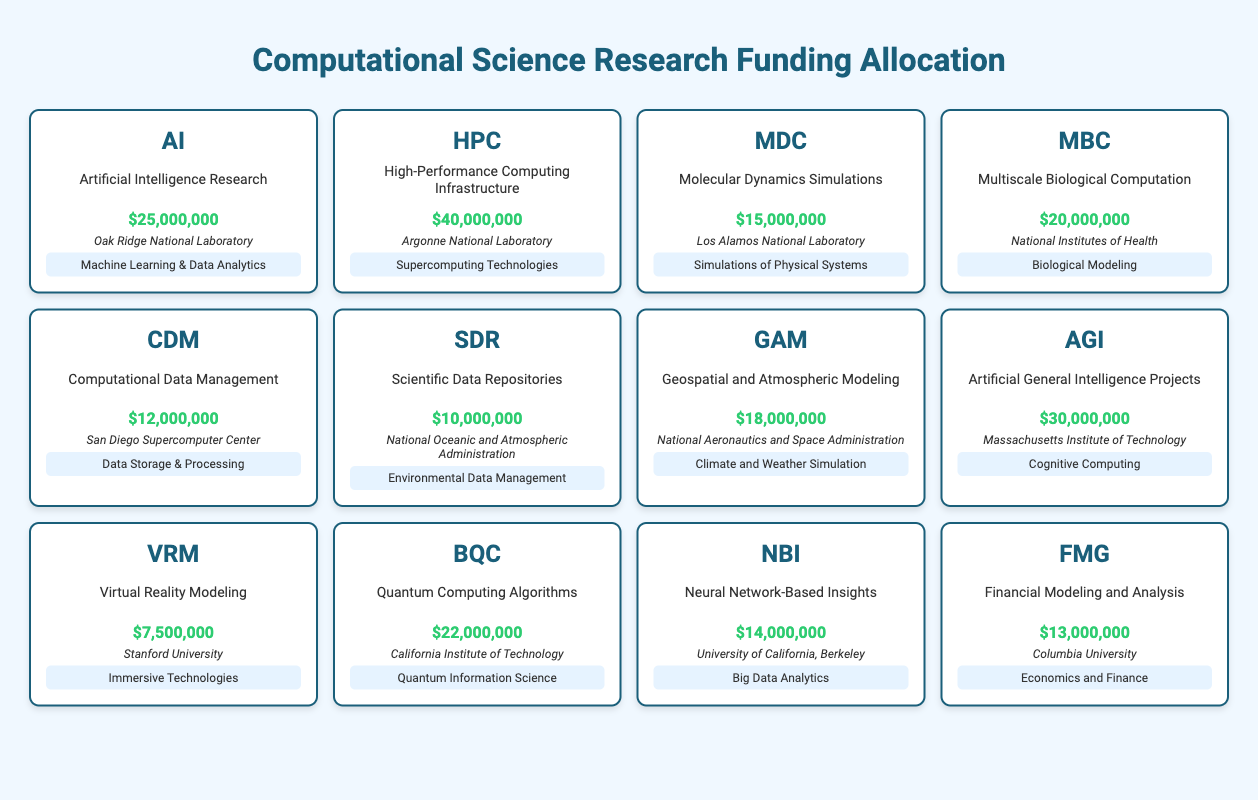What is the total funding for projects focusing on Machine Learning & Data Analytics? There is one project related to Machine Learning & Data Analytics, which is "Artificial Intelligence Research" with funding of 25,000,000. Therefore, the total funding for this focus area is 25,000,000.
Answer: 25,000,000 Which project received the highest funding and what is the amount? The project "High-Performance Computing Infrastructure" received the highest funding of 40,000,000.
Answer: High-Performance Computing Infrastructure, 40,000,000 How much more funding does the "Geospatial and Atmospheric Modeling" project have compared to the "Virtual Reality Modeling" project? "Geospatial and Atmospheric Modeling" has funding of 18,000,000 and "Virtual Reality Modeling" has funding of 7,500,000. So, the difference is 18,000,000 - 7,500,000 = 10,500,000.
Answer: 10,500,000 Is the funding for "Quantum Computing Algorithms" greater than that of "Neural Network-Based Insights"? "Quantum Computing Algorithms" has funding of 22,000,000, while "Neural Network-Based Insights" has funding of 14,000,000. Since 22,000,000 is greater than 14,000,000, the answer is yes.
Answer: Yes What is the average funding of the projects under the focus area "Biological Modeling"? There is one project in the "Biological Modeling" focus area, "Multiscale Biological Computation," with funding of 20,000,000. Therefore, the average funding for this area is 20,000,000 / 1 = 20,000,000.
Answer: 20,000,000 Which institution received funding for the project that focuses on Environmental Data Management, and what is the amount? The project "Scientific Data Repositories," which focuses on Environmental Data Management, received funding of 10,000,000. This project is managed by the National Oceanic and Atmospheric Administration.
Answer: National Oceanic and Atmospheric Administration, 10,000,000 What is the total funding for projects related to Artificial Intelligence? There are two projects in the Artificial Intelligence category: "Artificial Intelligence Research" funded at 25,000,000 and "Artificial General Intelligence Projects" funded at 30,000,000. The total funding is 25,000,000 + 30,000,000 = 55,000,000.
Answer: 55,000,000 Did "Financial Modeling and Analysis" receive more funding than "Computational Data Management"? "Financial Modeling and Analysis" received 13,000,000, while "Computational Data Management" received 12,000,000. Since 13,000,000 is greater than 12,000,000, the answer is yes.
Answer: Yes How many projects received funding of 20,000,000 or more? The projects that received funding of 20,000,000 or more are "High-Performance Computing Infrastructure" (40,000,000), "Artificial General Intelligence Projects" (30,000,000), and "Quantum Computing Algorithms" (22,000,000). That's 3 projects in total.
Answer: 3 